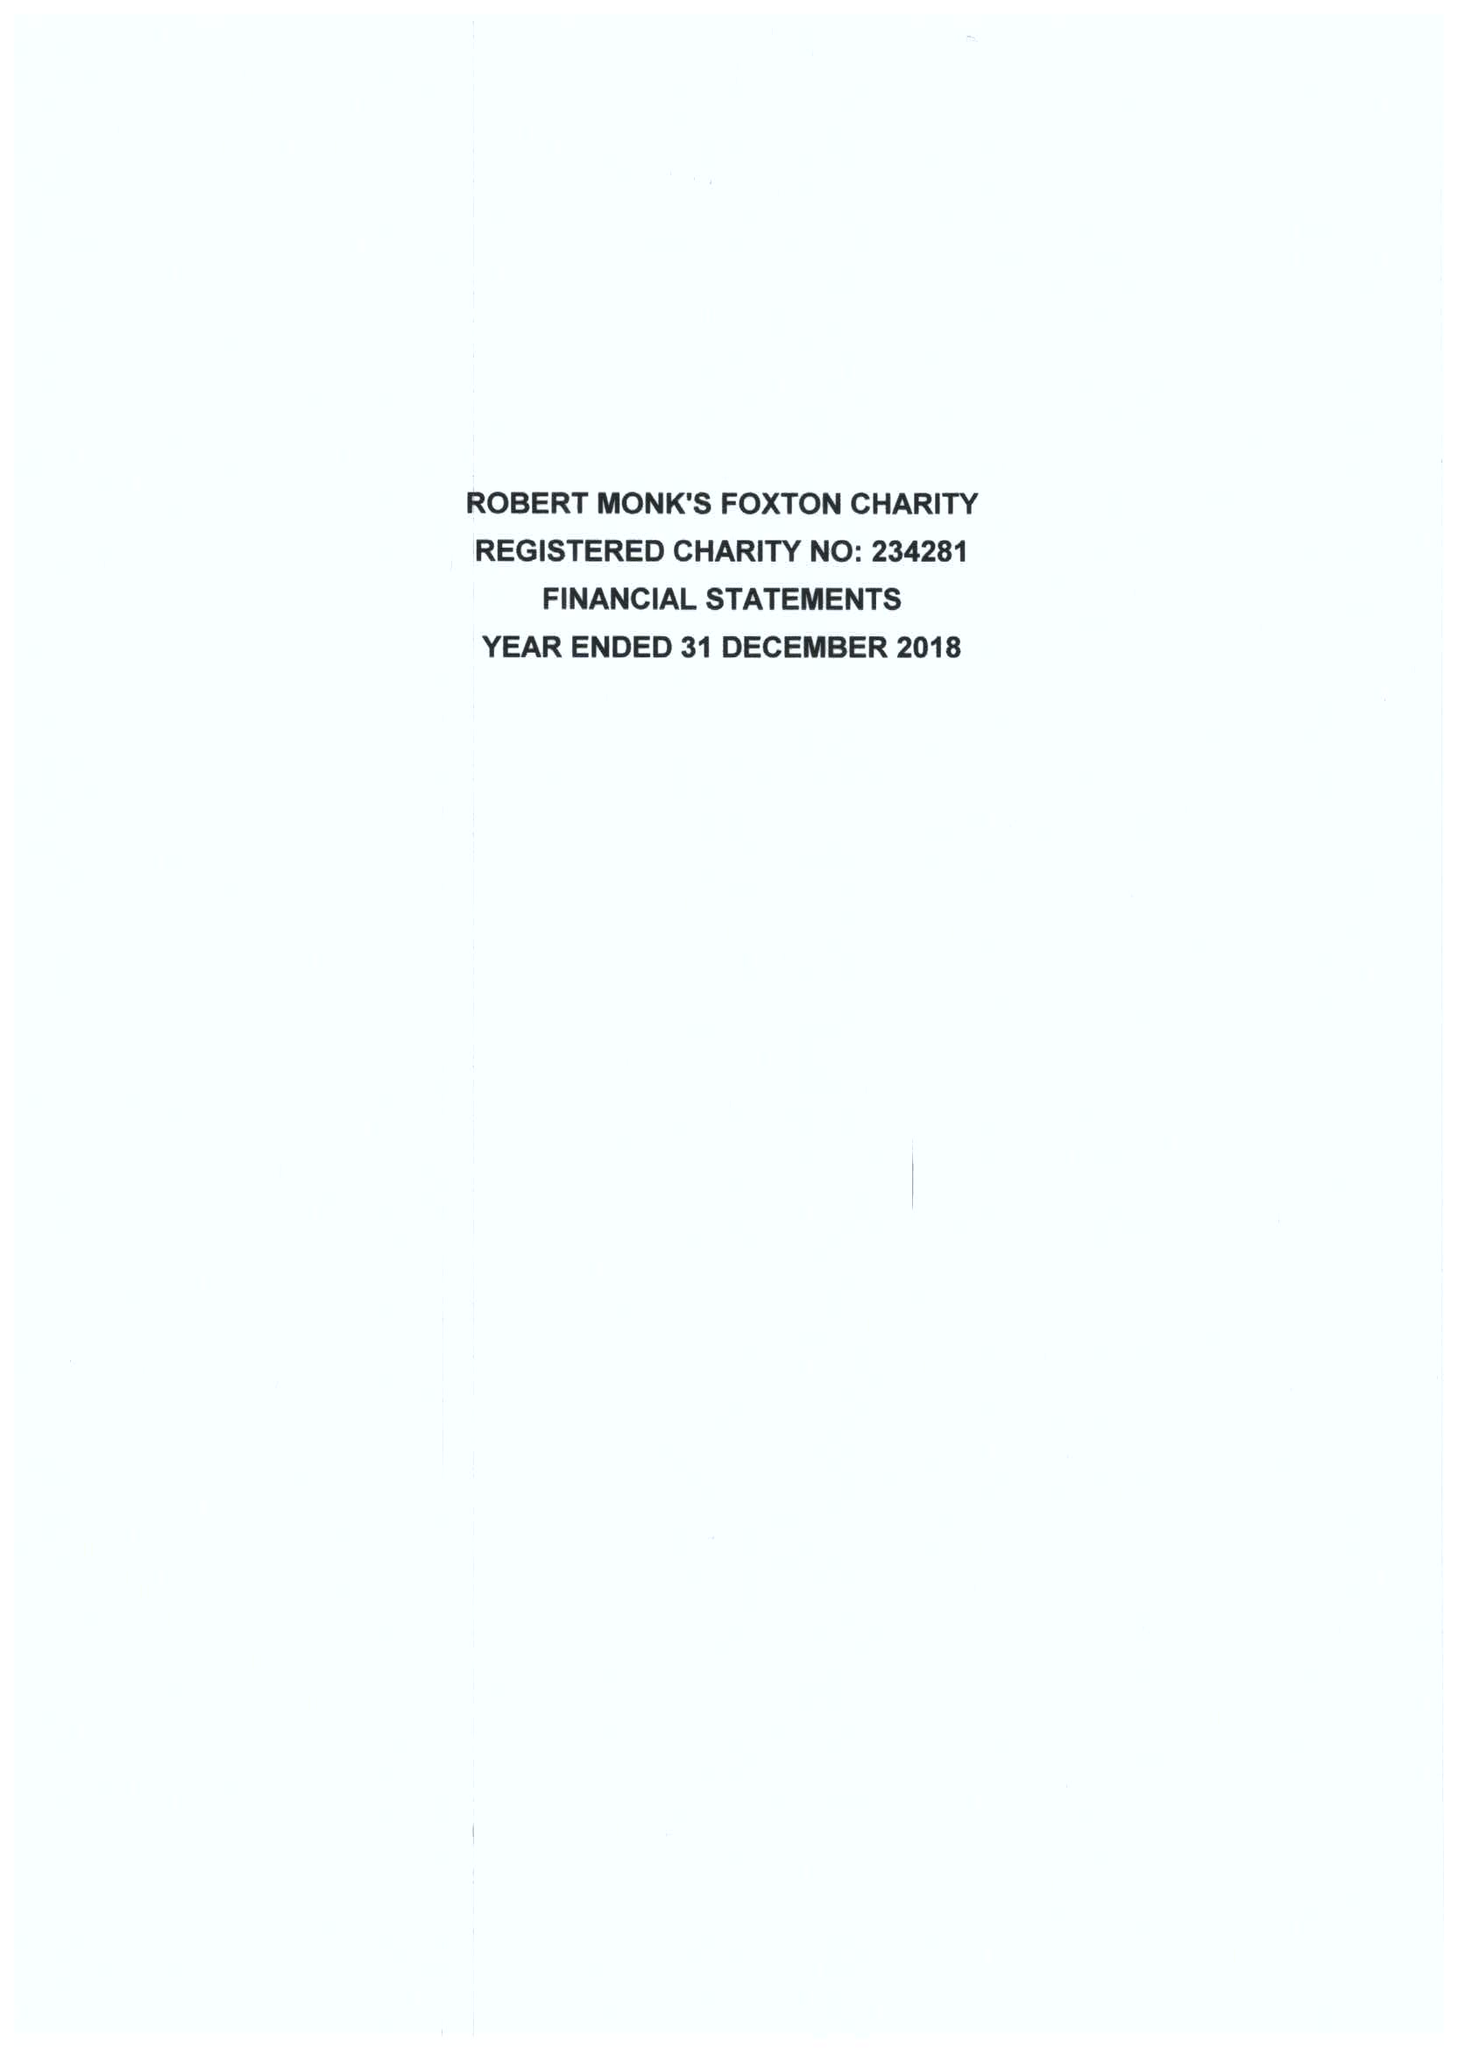What is the value for the address__post_town?
Answer the question using a single word or phrase. MARKET HARBOROUGH 